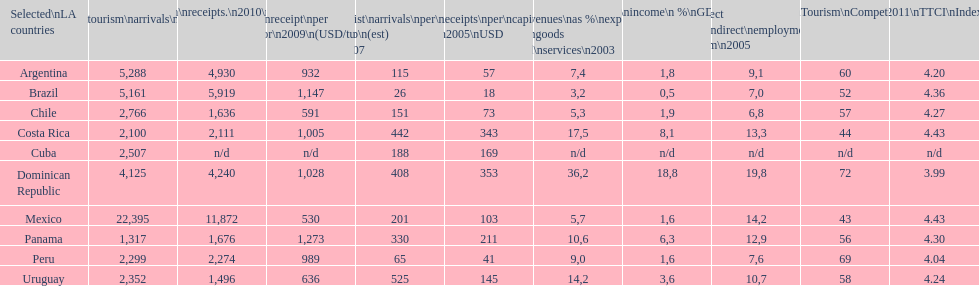Tourism income in latin american countries in 2003 was at most what percentage of gdp? 18,8. 